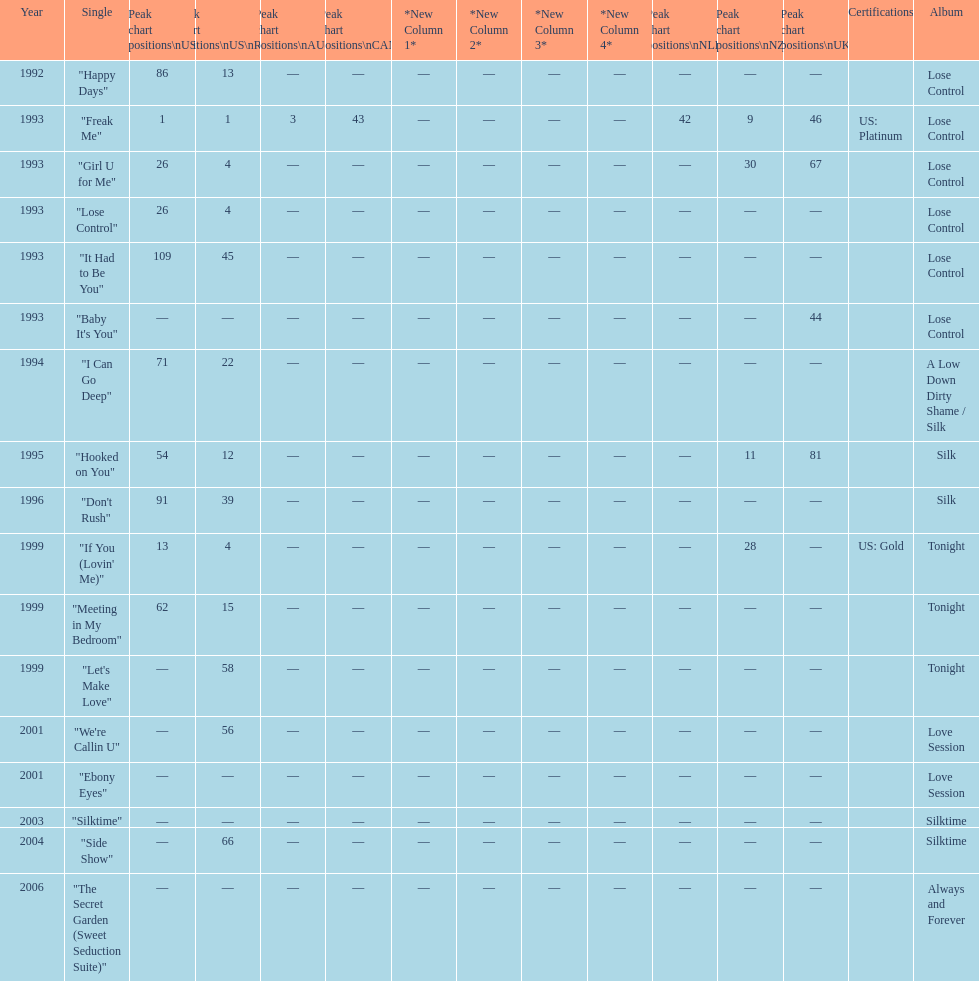Which single is the most in terms of how many times it charted? "Freak Me". Could you help me parse every detail presented in this table? {'header': ['Year', 'Single', 'Peak chart positions\\nUS', 'Peak chart positions\\nUS\\nR&B', 'Peak chart positions\\nAUS', 'Peak chart positions\\nCAN', '*New Column 1*', '*New Column 2*', '*New Column 3*', '*New Column 4*', 'Peak chart positions\\nNLD', 'Peak chart positions\\nNZ', 'Peak chart positions\\nUK', 'Certifications', 'Album'], 'rows': [['1992', '"Happy Days"', '86', '13', '—', '—', '—', '—', '—', '—', '—', '—', '—', '', 'Lose Control'], ['1993', '"Freak Me"', '1', '1', '3', '43', '—', '—', '—', '—', '42', '9', '46', 'US: Platinum', 'Lose Control'], ['1993', '"Girl U for Me"', '26', '4', '—', '—', '—', '—', '—', '—', '—', '30', '67', '', 'Lose Control'], ['1993', '"Lose Control"', '26', '4', '—', '—', '—', '—', '—', '—', '—', '—', '—', '', 'Lose Control'], ['1993', '"It Had to Be You"', '109', '45', '—', '—', '—', '—', '—', '—', '—', '—', '—', '', 'Lose Control'], ['1993', '"Baby It\'s You"', '—', '—', '—', '—', '—', '—', '—', '—', '—', '—', '44', '', 'Lose Control'], ['1994', '"I Can Go Deep"', '71', '22', '—', '—', '—', '—', '—', '—', '—', '—', '—', '', 'A Low Down Dirty Shame / Silk'], ['1995', '"Hooked on You"', '54', '12', '—', '—', '—', '—', '—', '—', '—', '11', '81', '', 'Silk'], ['1996', '"Don\'t Rush"', '91', '39', '—', '—', '—', '—', '—', '—', '—', '—', '—', '', 'Silk'], ['1999', '"If You (Lovin\' Me)"', '13', '4', '—', '—', '—', '—', '—', '—', '—', '28', '—', 'US: Gold', 'Tonight'], ['1999', '"Meeting in My Bedroom"', '62', '15', '—', '—', '—', '—', '—', '—', '—', '—', '—', '', 'Tonight'], ['1999', '"Let\'s Make Love"', '—', '58', '—', '—', '—', '—', '—', '—', '—', '—', '—', '', 'Tonight'], ['2001', '"We\'re Callin U"', '—', '56', '—', '—', '—', '—', '—', '—', '—', '—', '—', '', 'Love Session'], ['2001', '"Ebony Eyes"', '—', '—', '—', '—', '—', '—', '—', '—', '—', '—', '—', '', 'Love Session'], ['2003', '"Silktime"', '—', '—', '—', '—', '—', '—', '—', '—', '—', '—', '—', '', 'Silktime'], ['2004', '"Side Show"', '—', '66', '—', '—', '—', '—', '—', '—', '—', '—', '—', '', 'Silktime'], ['2006', '"The Secret Garden (Sweet Seduction Suite)"', '—', '—', '—', '—', '—', '—', '—', '—', '—', '—', '—', '', 'Always and Forever']]} 